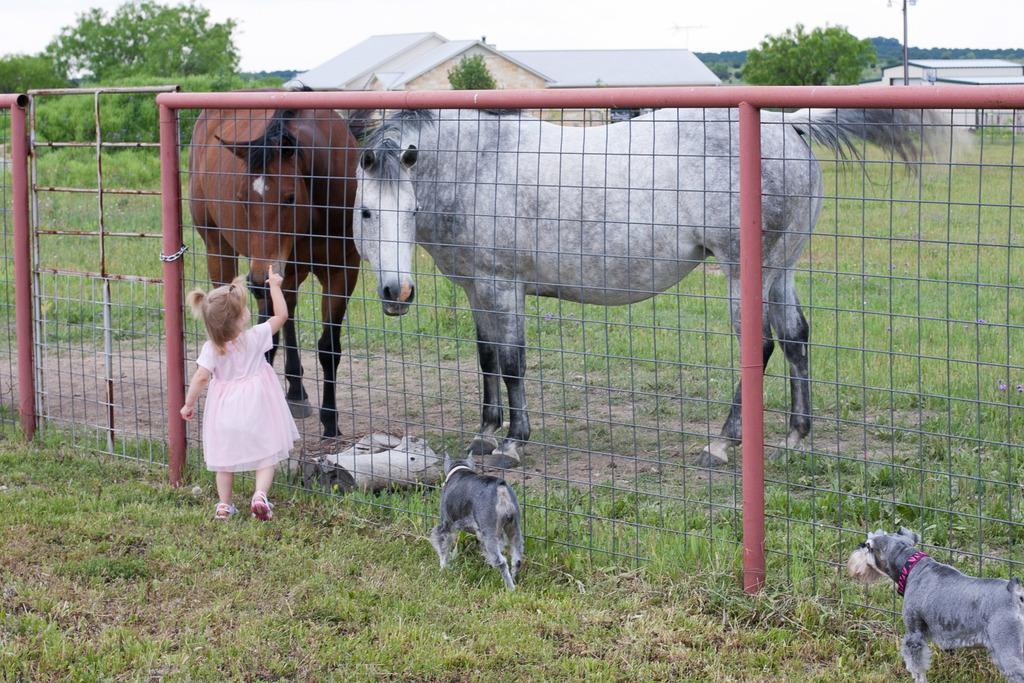Please provide a concise description of this image. In this image I see 2 horses and 2 dogs and a girl on the grass and I see a fence over here. In the background I see the trees and houses. 